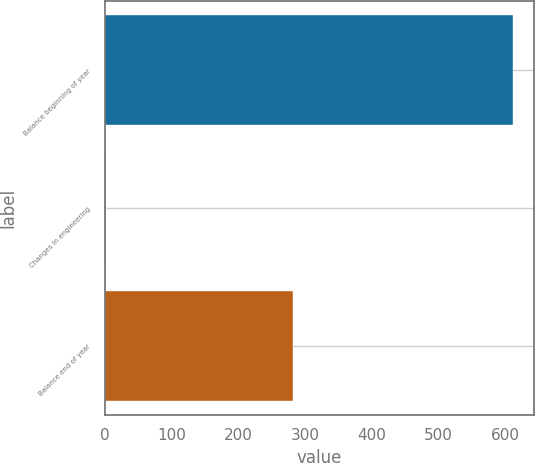<chart> <loc_0><loc_0><loc_500><loc_500><bar_chart><fcel>Balance beginning of year<fcel>Changes in engineering<fcel>Balance end of year<nl><fcel>612<fcel>1<fcel>282<nl></chart> 